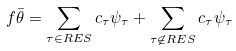Convert formula to latex. <formula><loc_0><loc_0><loc_500><loc_500>f \bar { \theta } = \sum _ { \tau \in R E S } c _ { \tau } \psi _ { \tau } + \sum _ { \tau \not \in R E S } c _ { \tau } \psi _ { \tau }</formula> 